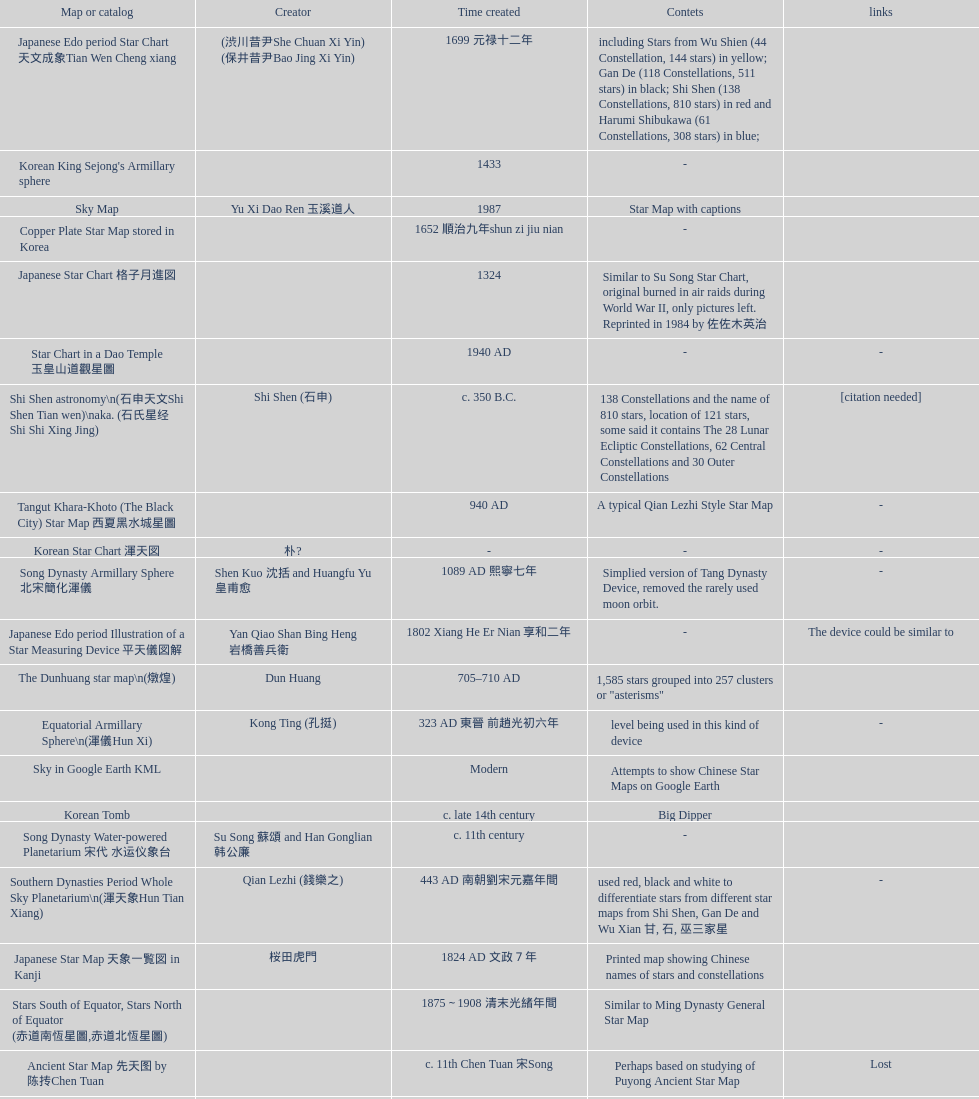What is the name of the oldest map/catalog? M45. 